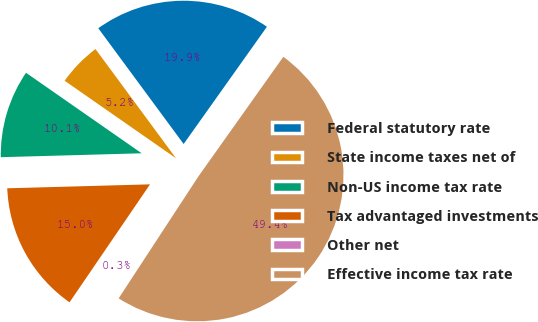<chart> <loc_0><loc_0><loc_500><loc_500><pie_chart><fcel>Federal statutory rate<fcel>State income taxes net of<fcel>Non-US income tax rate<fcel>Tax advantaged investments<fcel>Other net<fcel>Effective income tax rate<nl><fcel>19.94%<fcel>5.21%<fcel>10.12%<fcel>15.03%<fcel>0.31%<fcel>49.39%<nl></chart> 